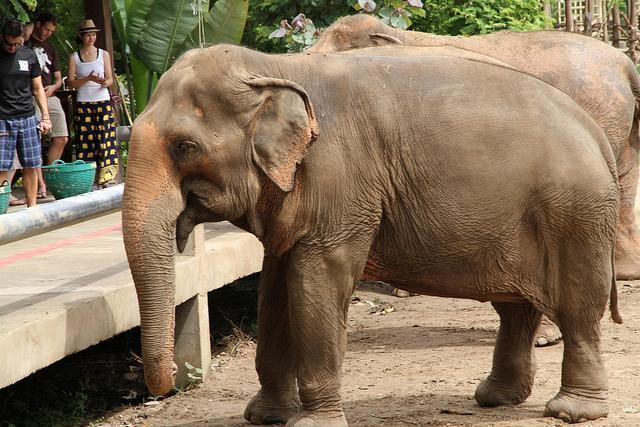How many people are wearing skirts?
Give a very brief answer. 1. How many people are visible?
Give a very brief answer. 3. How many elephants are in the picture?
Give a very brief answer. 2. How many black umbrellas are in the image?
Give a very brief answer. 0. 